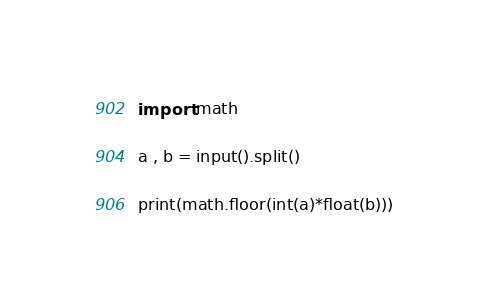<code> <loc_0><loc_0><loc_500><loc_500><_Python_>import math

a , b = input().split()

print(math.floor(int(a)*float(b)))</code> 